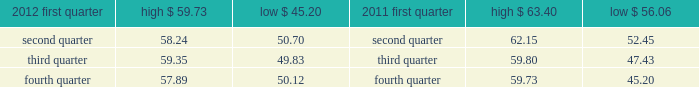( 5 ) we occupy approximately 350000 square feet of the one north end building .
( 6 ) this property is owned by board of trade investment company ( botic ) .
Kcbt maintains a 51% ( 51 % ) controlling interest in botic .
We also lease other office space around the world and have also partnered with major global telecommunications carriers in connection with our telecommunications hubs whereby we place data cabinets within the carriers 2019 existing secured data centers .
We believe our facilities are adequate for our current operations and that additional space can be obtained if needed .
Item 3 .
Legal proceedings see 201clegal and regulatory matters 201d in note 14 .
Contingencies to the consolidated financial statements beginning on page 91 for cme group 2019s legal proceedings disclosure which is incorporated herein by reference .
Item 4 .
Mine safety disclosures not applicable .
Part ii item 5 .
Market for registrant 2019s common equity , related stockholder matters and issuer purchases of equity securities class a common stock our class a common stock is currently listed on nasdaq under the ticker symbol 201ccme . 201d as of february 13 , 2013 , there were approximately 3106 holders of record of our class a common stock .
In may 2012 , the company 2019s board of directors declared a five-for-one split of its class a common stock effected by way of a stock dividend to its class a and class b shareholders .
The stock split was effective july 20 , 2012 for all shareholders of record on july 10 , 2012 .
As a result of the stock split , all amounts related to shares and per share amounts have been retroactively restated .
The table sets forth the high and low sales prices per share of our class a common stock on a quarterly basis , as reported on nasdaq. .
Class b common stock our class b common stock is not listed on a national securities exchange or traded in an organized over- the-counter market .
Each class of our class b common stock is associated with a membership in a specific division of our cme exchange .
Cme 2019s rules provide exchange members with trading rights and the ability to use or lease these trading rights .
Each share of our class b common stock can be transferred only in connection with the transfer of the associated trading rights. .
What is the maximum change in share price during the first quarter of 2012? 
Computations: (59.73 - 45.20)
Answer: 14.53. 